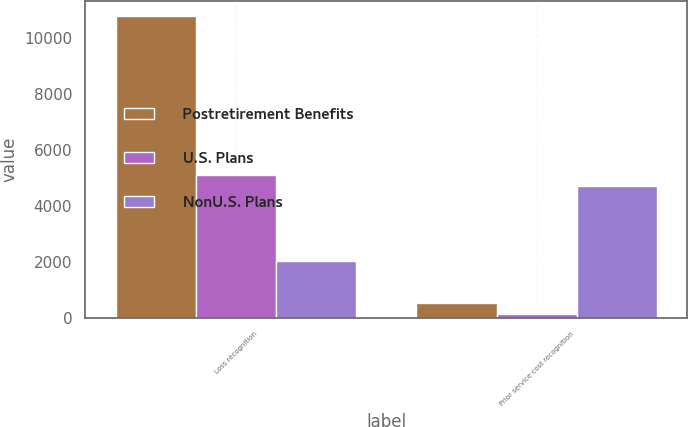Convert chart. <chart><loc_0><loc_0><loc_500><loc_500><stacked_bar_chart><ecel><fcel>Loss recognition<fcel>Prior service cost recognition<nl><fcel>Postretirement Benefits<fcel>10773<fcel>515<nl><fcel>U.S. Plans<fcel>5084<fcel>143<nl><fcel>NonU.S. Plans<fcel>2032<fcel>4719<nl></chart> 